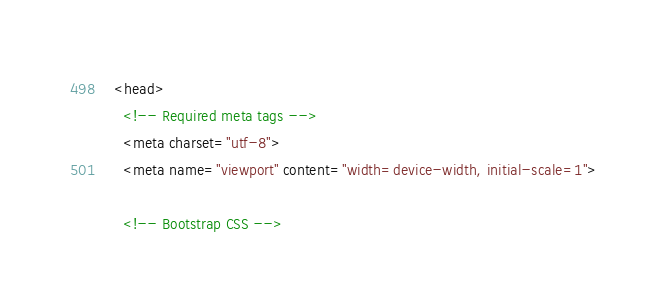<code> <loc_0><loc_0><loc_500><loc_500><_HTML_>  <head>
    <!-- Required meta tags -->
    <meta charset="utf-8">
    <meta name="viewport" content="width=device-width, initial-scale=1">

    <!-- Bootstrap CSS --></code> 